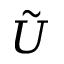Convert formula to latex. <formula><loc_0><loc_0><loc_500><loc_500>\tilde { U }</formula> 